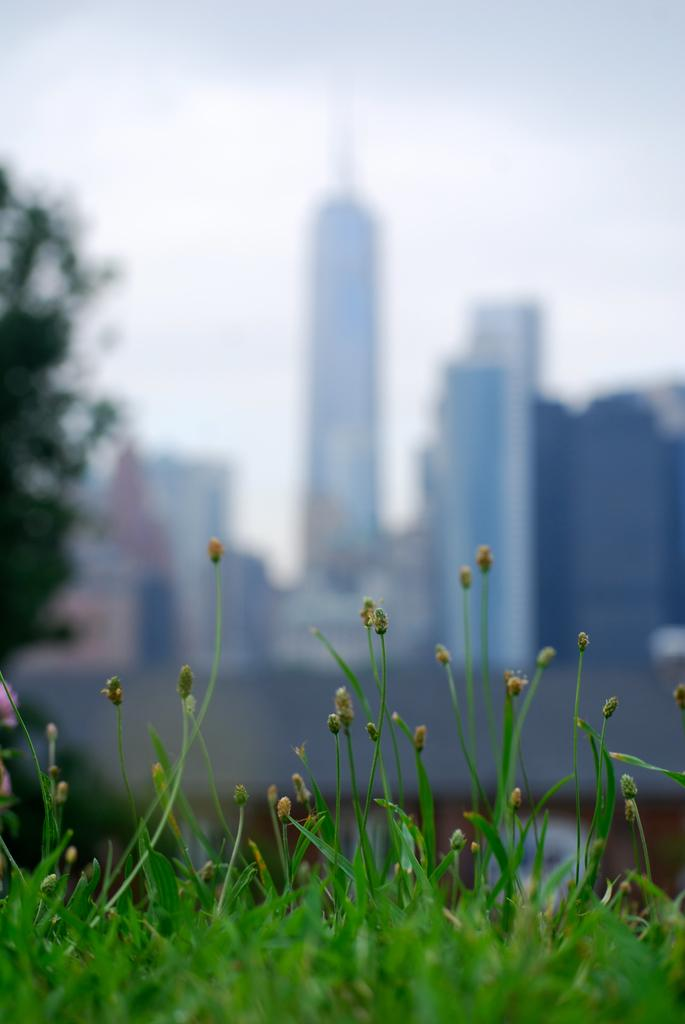What type of vegetation is present on the ground in the image? There is green grass on the ground in the image. What can be seen to the left in the image? There is a tree to the left in the image. What type of structures are visible in the background of the image? There are skyscrapers in the background of the image. How would you describe the appearance of the background in the image? The background appears blurred. What type of curtain is hanging in front of the skyscrapers in the image? There is no curtain present in the image; the skyscrapers are visible in the background. How can the image be adjusted to make the skyscrapers more visible? The image cannot be adjusted in this conversation, as we are only discussing the information provided in the facts. 